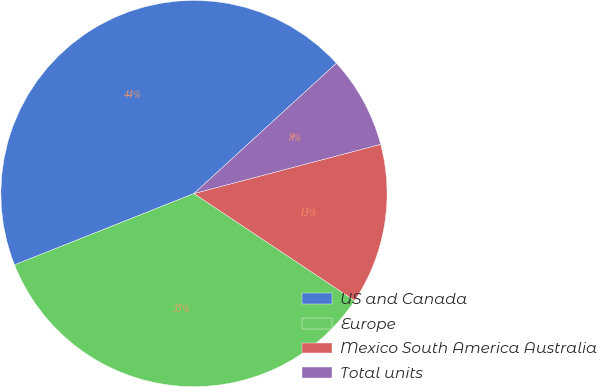<chart> <loc_0><loc_0><loc_500><loc_500><pie_chart><fcel>US and Canada<fcel>Europe<fcel>Mexico South America Australia<fcel>Total units<nl><fcel>44.23%<fcel>34.62%<fcel>13.46%<fcel>7.69%<nl></chart> 